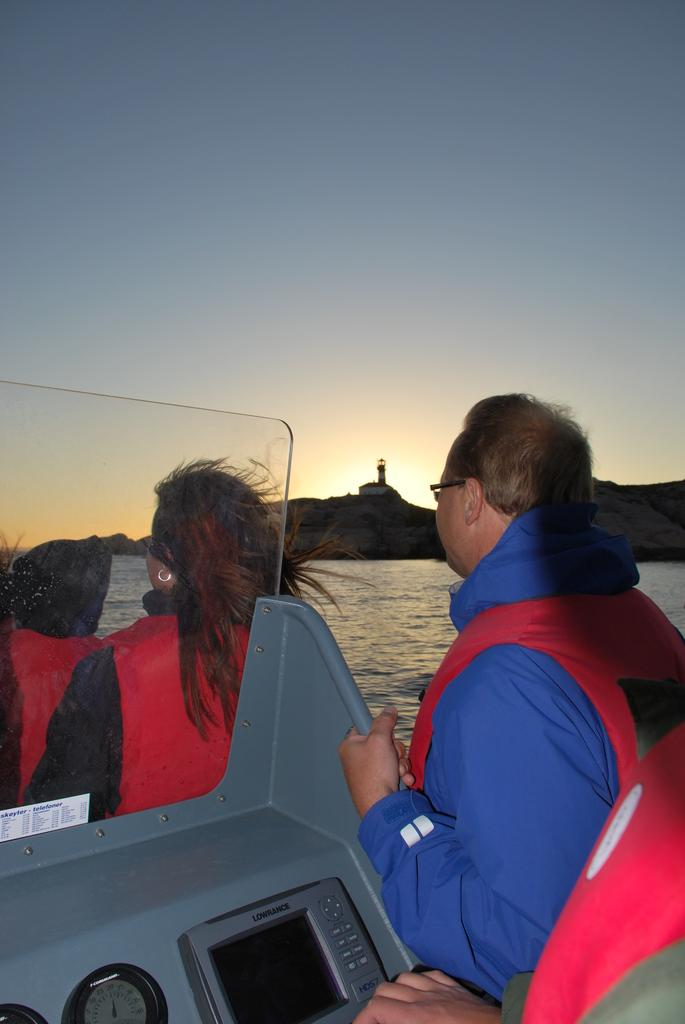How many people are in the boat in the image? There are four persons standing in the boat. What is visible in the background of the image? There is water, a house, a tower, a mountain, and the sky visible in the background. What type of structure can be seen in the background? There is a tower in the background. What natural feature is visible in the background? There is a mountain in the background. What type of hammer is being used by the visitor in the image? There is no visitor or hammer present in the image. What type of pest can be seen crawling on the mountain in the image? There are no pests visible in the image; only the boat, people, and background elements are present. 